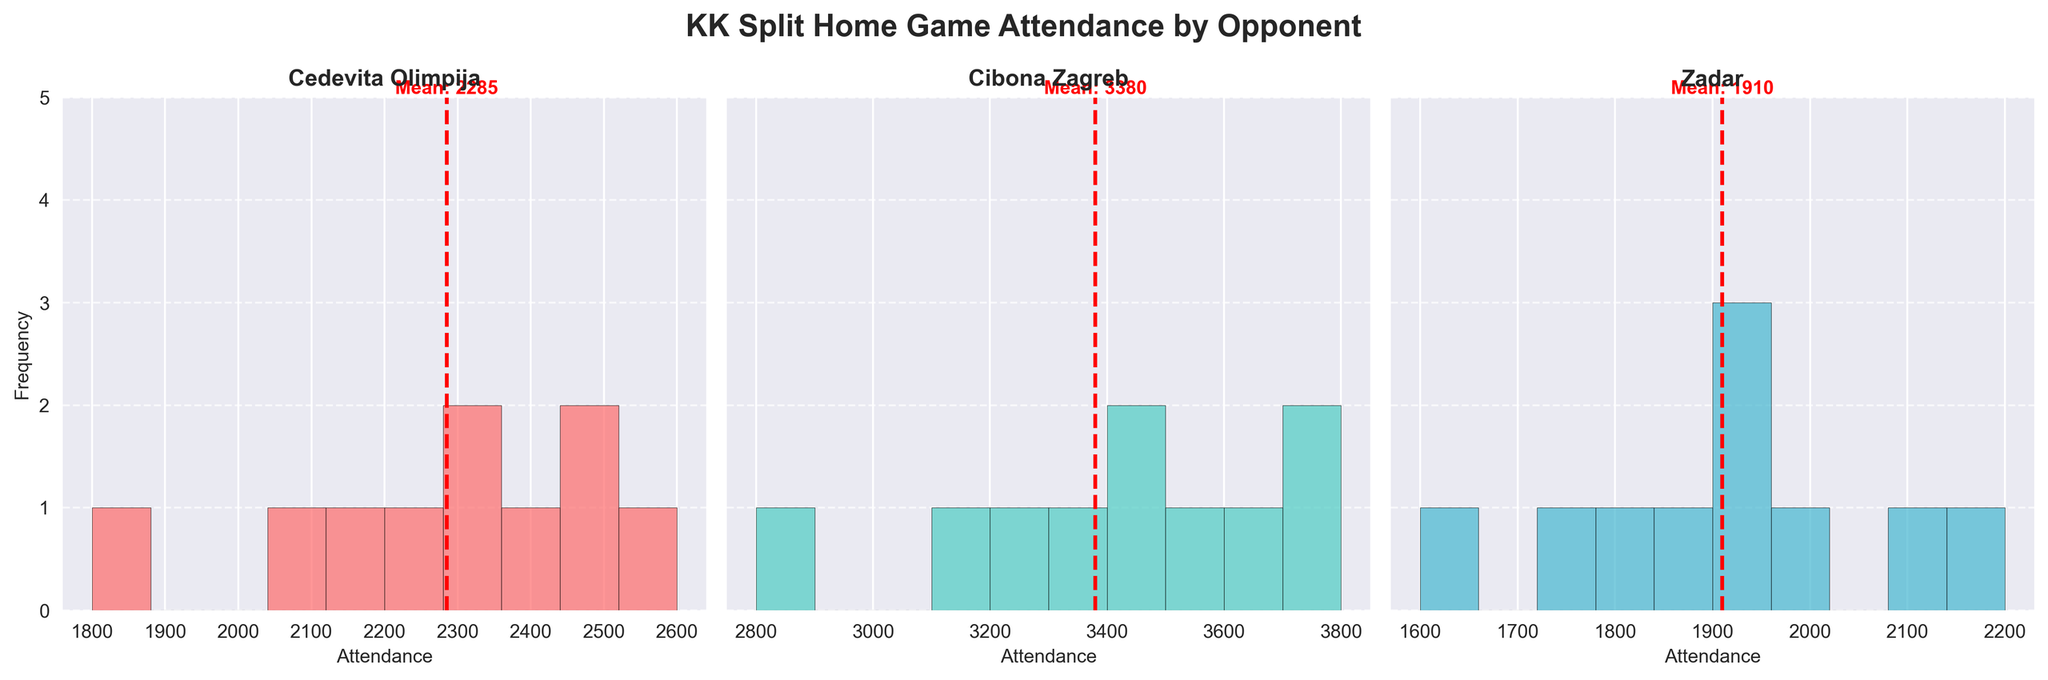What is the title of the figure? The title of the figure is at the top of the plot and reads 'KK Split Home Game Attendance by Opponent'.
Answer: KK Split Home Game Attendance by Opponent How many subplots are there in the figure? The figure consists of three subplots, one for each opponent.
Answer: Three What are the opponents displayed in the subplots? The opponents are displayed in the title of each subplot. They are Cedevita Olimpija, Cibona Zagreb, and Zadar.
Answer: Cedevita Olimpija, Cibona Zagreb, Zadar Which opponent has the highest mean attendance? Each subplot has a dashed red mean line. Cibona Zagreb's subplot shows the highest mean, which is indicated near the top of its subplot.
Answer: Cibona Zagreb Which opponent has the lowest mean attendance? By examining the mean lines in the subplots, the mean attendance for Zadar is the lowest.
Answer: Zadar What is the color of the bars for Cibona Zagreb? The color of the bars for each opponent is different. Cibona Zagreb's bars are in a light green color.
Answer: Light green Does any of the opponents' attendance have a frequency of 4 or more for any attendance bin? By checking the heights of the bars in each subplot, none of the attendance bins for any opponent reach a frequency of 4 or more.
Answer: No What is the mean attendance for Zadar? The mean attendance is indicated by the red dashed line in each subplot. For Zadar, the mean attendance is labeled as approximately 1970.
Answer: 1970 Compare the variability of attendance between Zadar and Cibona Zagreb. Which opponent shows more variability? The widths of the attendance distributions and frequency of the bars indicate variability. Zadar has a wider spread and varying frequencies, indicating more variability compared to the more clustered distribution of Cibona Zagreb.
Answer: Zadar 